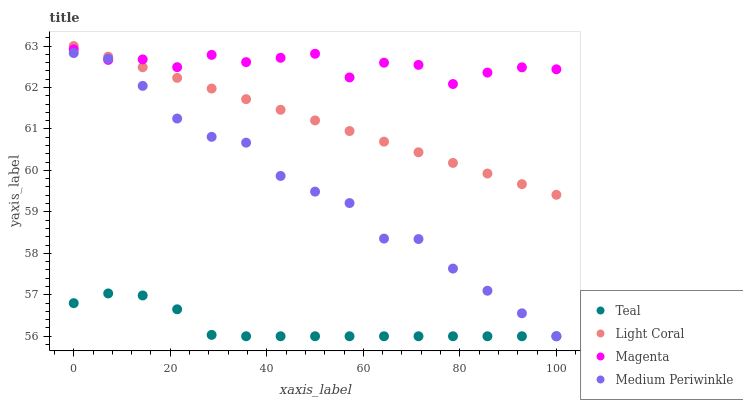Does Teal have the minimum area under the curve?
Answer yes or no. Yes. Does Magenta have the maximum area under the curve?
Answer yes or no. Yes. Does Medium Periwinkle have the minimum area under the curve?
Answer yes or no. No. Does Medium Periwinkle have the maximum area under the curve?
Answer yes or no. No. Is Light Coral the smoothest?
Answer yes or no. Yes. Is Magenta the roughest?
Answer yes or no. Yes. Is Medium Periwinkle the smoothest?
Answer yes or no. No. Is Medium Periwinkle the roughest?
Answer yes or no. No. Does Medium Periwinkle have the lowest value?
Answer yes or no. Yes. Does Magenta have the lowest value?
Answer yes or no. No. Does Light Coral have the highest value?
Answer yes or no. Yes. Does Magenta have the highest value?
Answer yes or no. No. Is Teal less than Magenta?
Answer yes or no. Yes. Is Light Coral greater than Teal?
Answer yes or no. Yes. Does Magenta intersect Medium Periwinkle?
Answer yes or no. Yes. Is Magenta less than Medium Periwinkle?
Answer yes or no. No. Is Magenta greater than Medium Periwinkle?
Answer yes or no. No. Does Teal intersect Magenta?
Answer yes or no. No. 